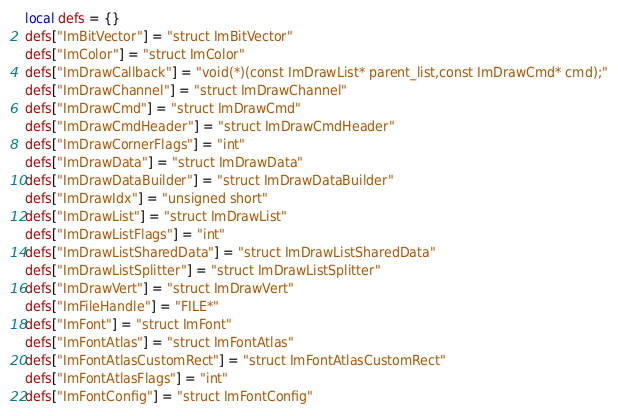Convert code to text. <code><loc_0><loc_0><loc_500><loc_500><_Lua_>local defs = {}
defs["ImBitVector"] = "struct ImBitVector"
defs["ImColor"] = "struct ImColor"
defs["ImDrawCallback"] = "void(*)(const ImDrawList* parent_list,const ImDrawCmd* cmd);"
defs["ImDrawChannel"] = "struct ImDrawChannel"
defs["ImDrawCmd"] = "struct ImDrawCmd"
defs["ImDrawCmdHeader"] = "struct ImDrawCmdHeader"
defs["ImDrawCornerFlags"] = "int"
defs["ImDrawData"] = "struct ImDrawData"
defs["ImDrawDataBuilder"] = "struct ImDrawDataBuilder"
defs["ImDrawIdx"] = "unsigned short"
defs["ImDrawList"] = "struct ImDrawList"
defs["ImDrawListFlags"] = "int"
defs["ImDrawListSharedData"] = "struct ImDrawListSharedData"
defs["ImDrawListSplitter"] = "struct ImDrawListSplitter"
defs["ImDrawVert"] = "struct ImDrawVert"
defs["ImFileHandle"] = "FILE*"
defs["ImFont"] = "struct ImFont"
defs["ImFontAtlas"] = "struct ImFontAtlas"
defs["ImFontAtlasCustomRect"] = "struct ImFontAtlasCustomRect"
defs["ImFontAtlasFlags"] = "int"
defs["ImFontConfig"] = "struct ImFontConfig"</code> 